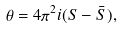Convert formula to latex. <formula><loc_0><loc_0><loc_500><loc_500>\theta = 4 \pi ^ { 2 } i ( S - \bar { S } ) ,</formula> 